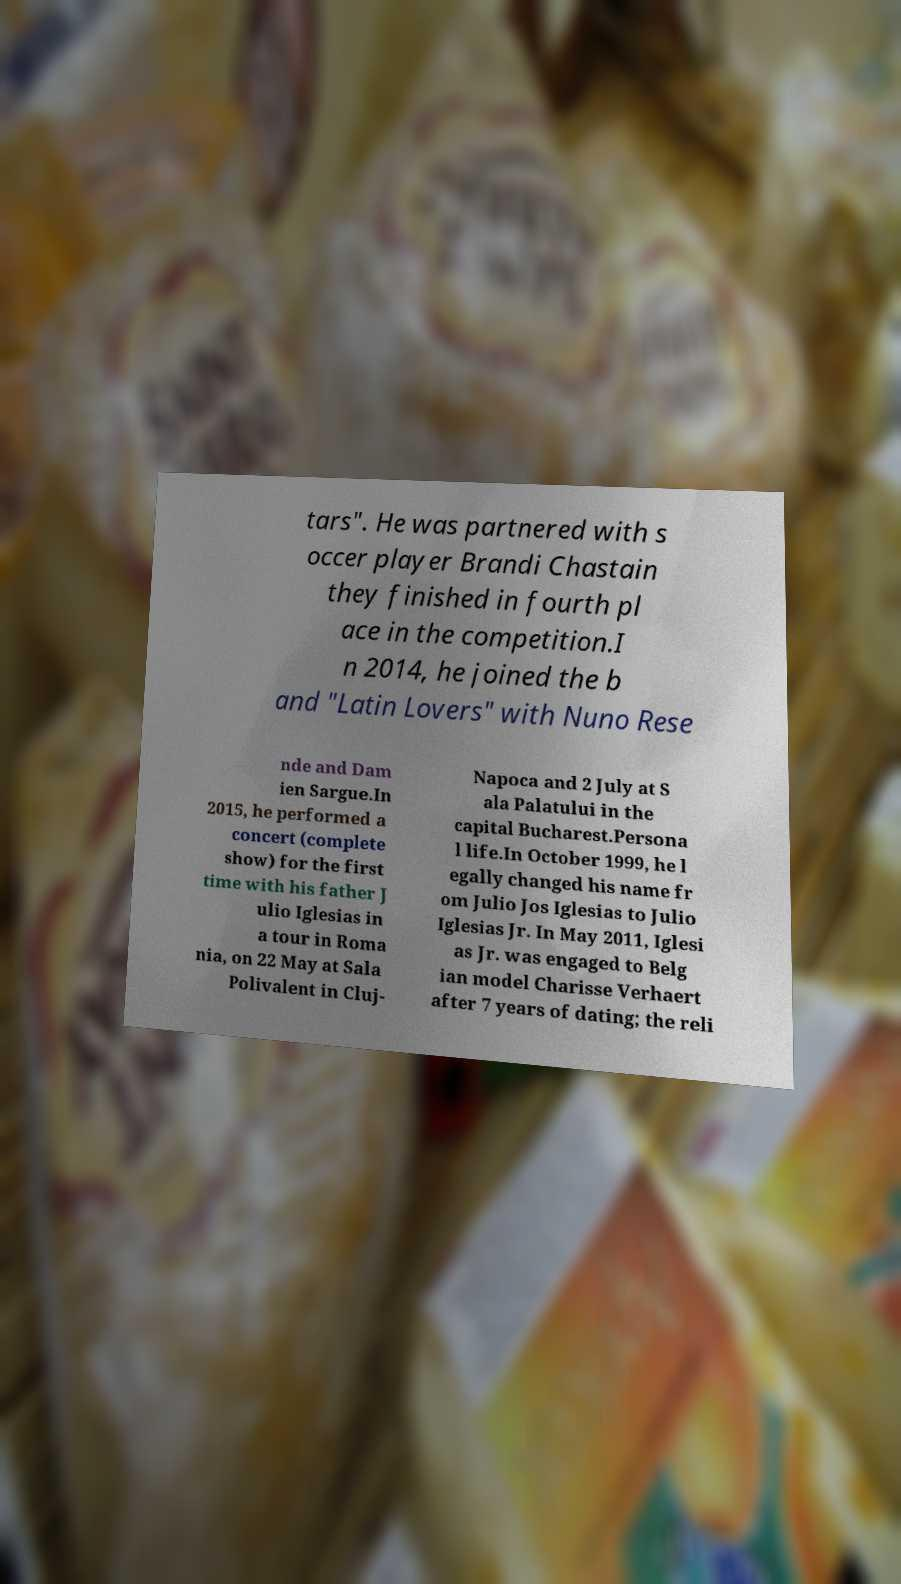For documentation purposes, I need the text within this image transcribed. Could you provide that? tars". He was partnered with s occer player Brandi Chastain they finished in fourth pl ace in the competition.I n 2014, he joined the b and "Latin Lovers" with Nuno Rese nde and Dam ien Sargue.In 2015, he performed a concert (complete show) for the first time with his father J ulio Iglesias in a tour in Roma nia, on 22 May at Sala Polivalent in Cluj- Napoca and 2 July at S ala Palatului in the capital Bucharest.Persona l life.In October 1999, he l egally changed his name fr om Julio Jos Iglesias to Julio Iglesias Jr. In May 2011, Iglesi as Jr. was engaged to Belg ian model Charisse Verhaert after 7 years of dating; the reli 